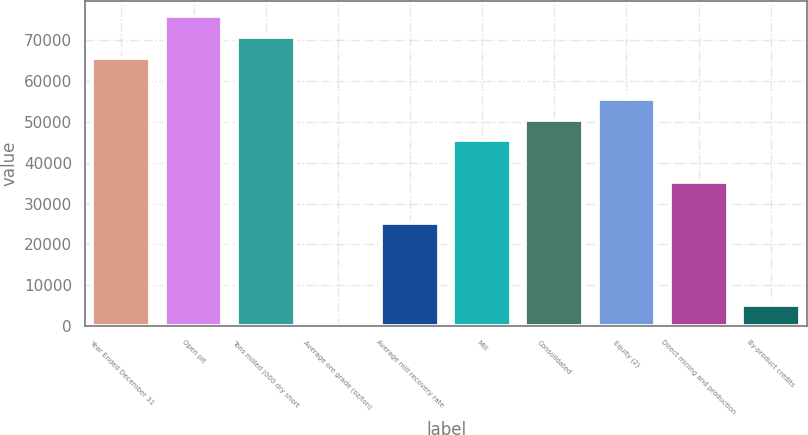Convert chart to OTSL. <chart><loc_0><loc_0><loc_500><loc_500><bar_chart><fcel>Year Ended December 31<fcel>Open pit<fcel>Tons milled (000 dry short<fcel>Average ore grade (oz/ton)<fcel>Average mill recovery rate<fcel>Mill<fcel>Consolidated<fcel>Equity (2)<fcel>Direct mining and production<fcel>By-product credits<nl><fcel>65737<fcel>75850.4<fcel>70793.7<fcel>0.07<fcel>25283.5<fcel>45510.3<fcel>50567<fcel>55623.7<fcel>35396.9<fcel>5056.76<nl></chart> 